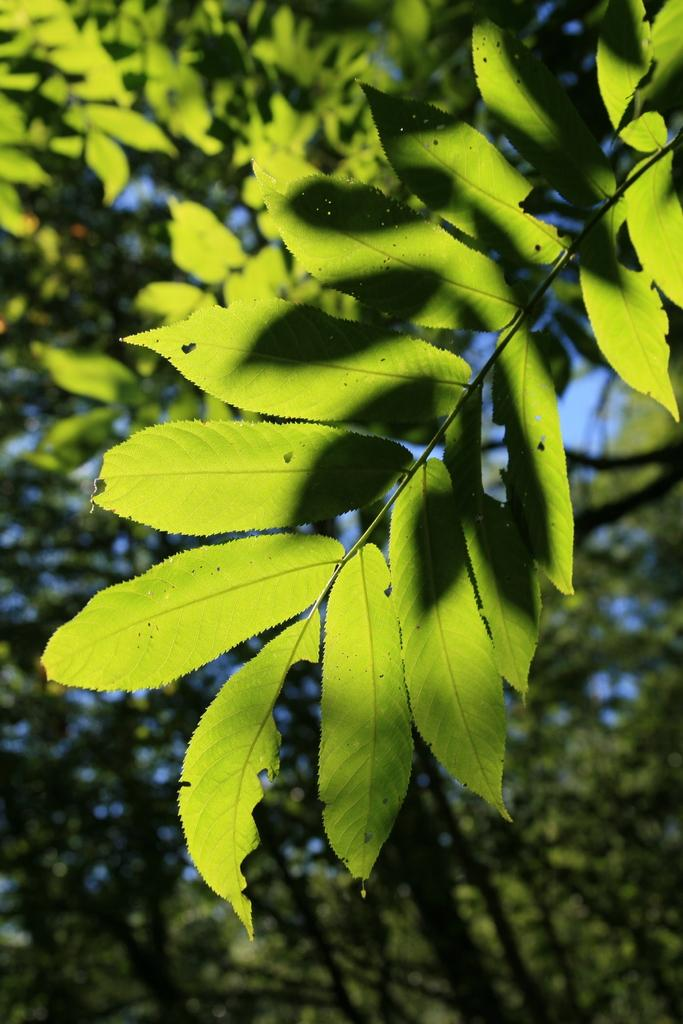What type of vegetation can be seen in the image? There are trees in the image. Can you describe the trees in the image? The provided facts do not include specific details about the trees, so we cannot describe them further. How many clovers are growing among the trees in the image? There is no mention of clovers in the image, so we cannot determine their presence or quantity. 